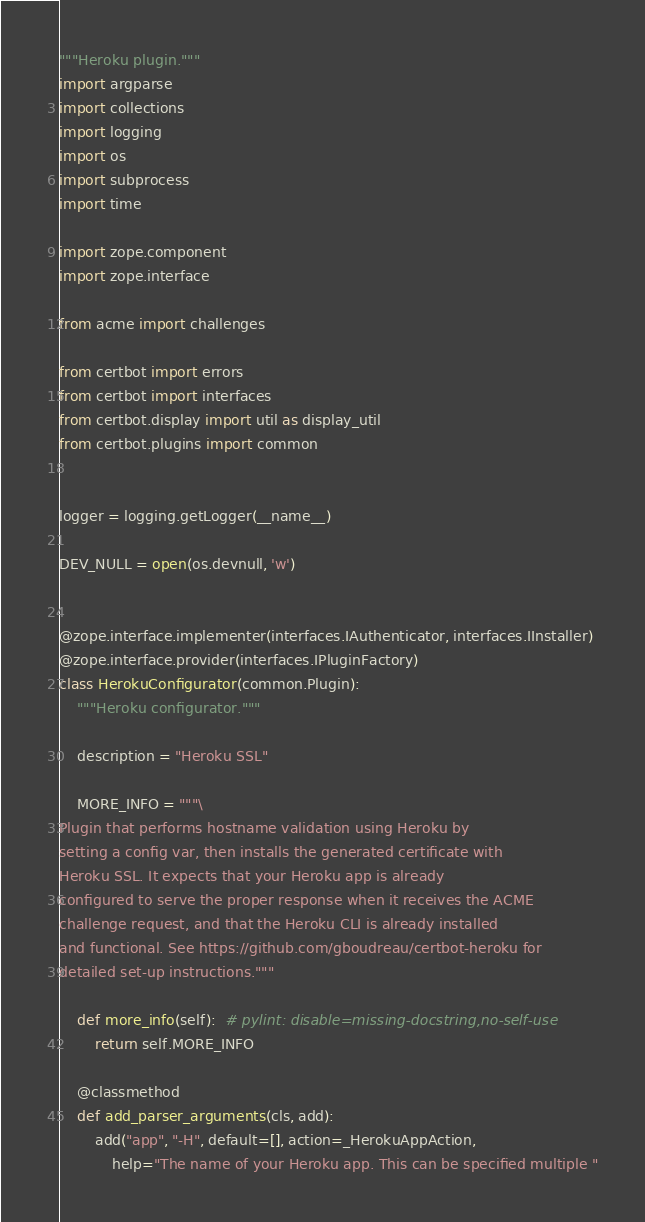<code> <loc_0><loc_0><loc_500><loc_500><_Python_>"""Heroku plugin."""
import argparse
import collections
import logging
import os
import subprocess
import time

import zope.component
import zope.interface

from acme import challenges

from certbot import errors
from certbot import interfaces
from certbot.display import util as display_util
from certbot.plugins import common


logger = logging.getLogger(__name__)

DEV_NULL = open(os.devnull, 'w')


@zope.interface.implementer(interfaces.IAuthenticator, interfaces.IInstaller)
@zope.interface.provider(interfaces.IPluginFactory)
class HerokuConfigurator(common.Plugin):
    """Heroku configurator."""

    description = "Heroku SSL"

    MORE_INFO = """\
Plugin that performs hostname validation using Heroku by
setting a config var, then installs the generated certificate with
Heroku SSL. It expects that your Heroku app is already
configured to serve the proper response when it receives the ACME
challenge request, and that the Heroku CLI is already installed
and functional. See https://github.com/gboudreau/certbot-heroku for
detailed set-up instructions."""

    def more_info(self):  # pylint: disable=missing-docstring,no-self-use
        return self.MORE_INFO

    @classmethod
    def add_parser_arguments(cls, add):
        add("app", "-H", default=[], action=_HerokuAppAction,
            help="The name of your Heroku app. This can be specified multiple "</code> 